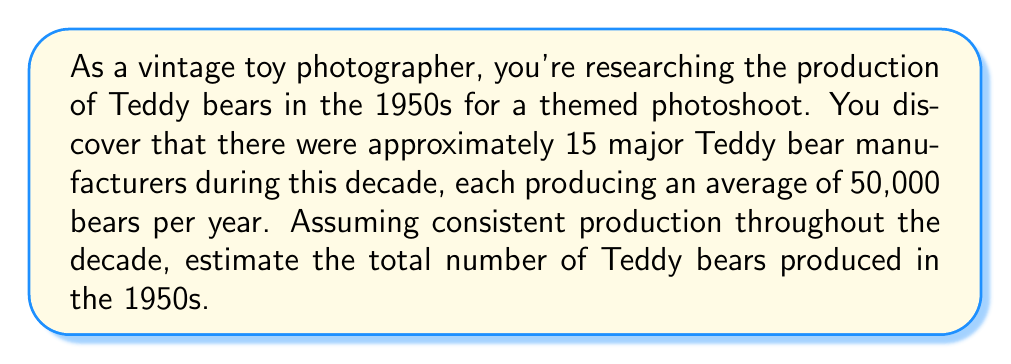What is the answer to this math problem? To estimate the total number of Teddy bears produced in the 1950s, we need to consider the following information:

1. Number of major manufacturers: 15
2. Average production per manufacturer per year: 50,000
3. Duration: 10 years (1950-1959)

We can use the following formula to calculate the total production:

$$ \text{Total Production} = \text{Number of Manufacturers} \times \text{Average Annual Production} \times \text{Number of Years} $$

Let's plug in the values:

$$ \text{Total Production} = 15 \times 50,000 \times 10 $$

Now, let's calculate:

$$ \begin{align*}
\text{Total Production} &= 15 \times 50,000 \times 10 \\
&= 750,000 \times 10 \\
&= 7,500,000
\end{align*} $$

Therefore, we estimate that approximately 7.5 million Teddy bears were produced in the 1950s.
Answer: Approximately 7,500,000 Teddy bears 